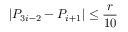<formula> <loc_0><loc_0><loc_500><loc_500>| P _ { 3 i - 2 } - P _ { i + 1 } | \leq \frac { r } { 1 0 }</formula> 